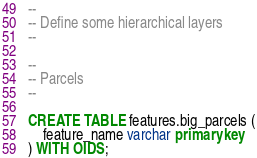<code> <loc_0><loc_0><loc_500><loc_500><_SQL_>--
-- Define some hierarchical layers
--

--
-- Parcels
--

CREATE TABLE features.big_parcels (
	feature_name varchar primary key
) WITH OIDS;
</code> 